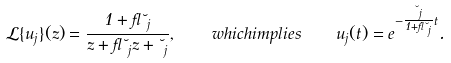<formula> <loc_0><loc_0><loc_500><loc_500>\mathcal { L } \{ u _ { j } \} ( z ) = \frac { 1 + \gamma \lambda _ { j } } { z + \gamma \lambda _ { j } z + \lambda _ { j } } , \quad w h i c h i m p l i e s \quad u _ { j } ( t ) = e ^ { - \frac { \lambda _ { j } } { 1 + \gamma \lambda _ { j } } t } .</formula> 